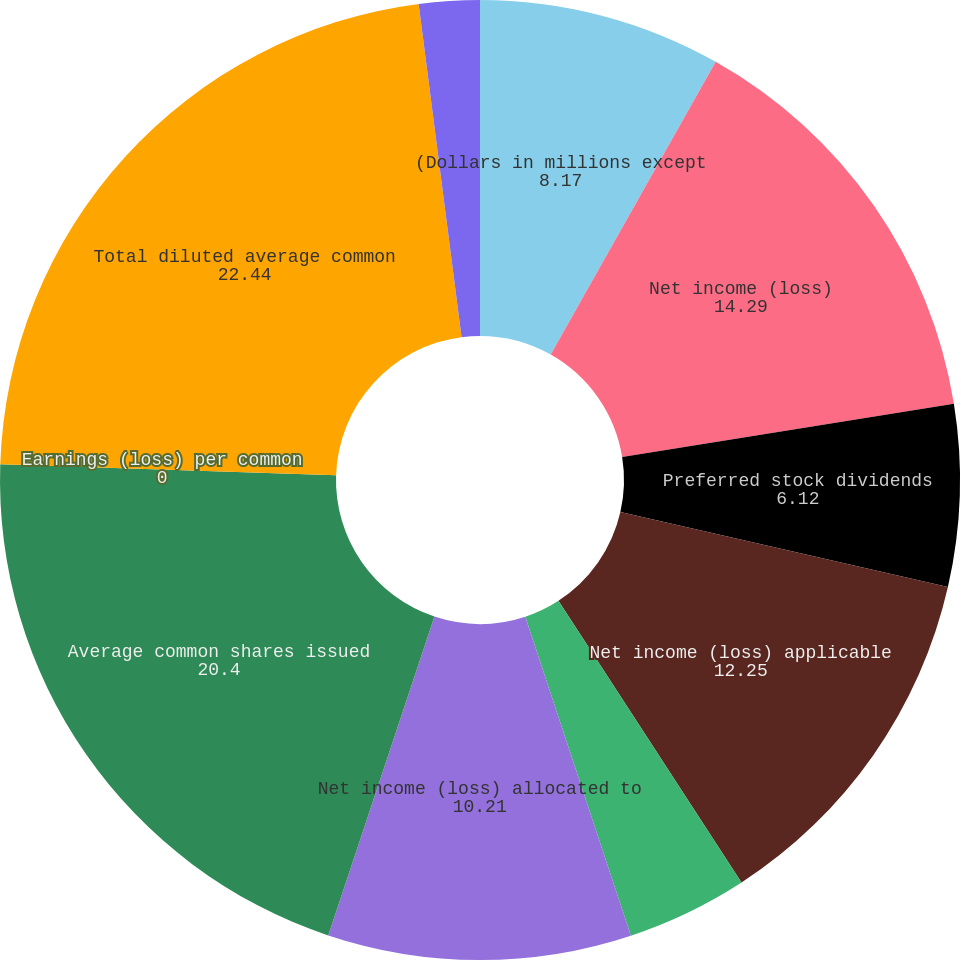Convert chart. <chart><loc_0><loc_0><loc_500><loc_500><pie_chart><fcel>(Dollars in millions except<fcel>Net income (loss)<fcel>Preferred stock dividends<fcel>Net income (loss) applicable<fcel>Dividends and undistributed<fcel>Net income (loss) allocated to<fcel>Average common shares issued<fcel>Earnings (loss) per common<fcel>Total diluted average common<fcel>Diluted earnings (loss) per<nl><fcel>8.17%<fcel>14.29%<fcel>6.12%<fcel>12.25%<fcel>4.08%<fcel>10.21%<fcel>20.4%<fcel>0.0%<fcel>22.44%<fcel>2.04%<nl></chart> 